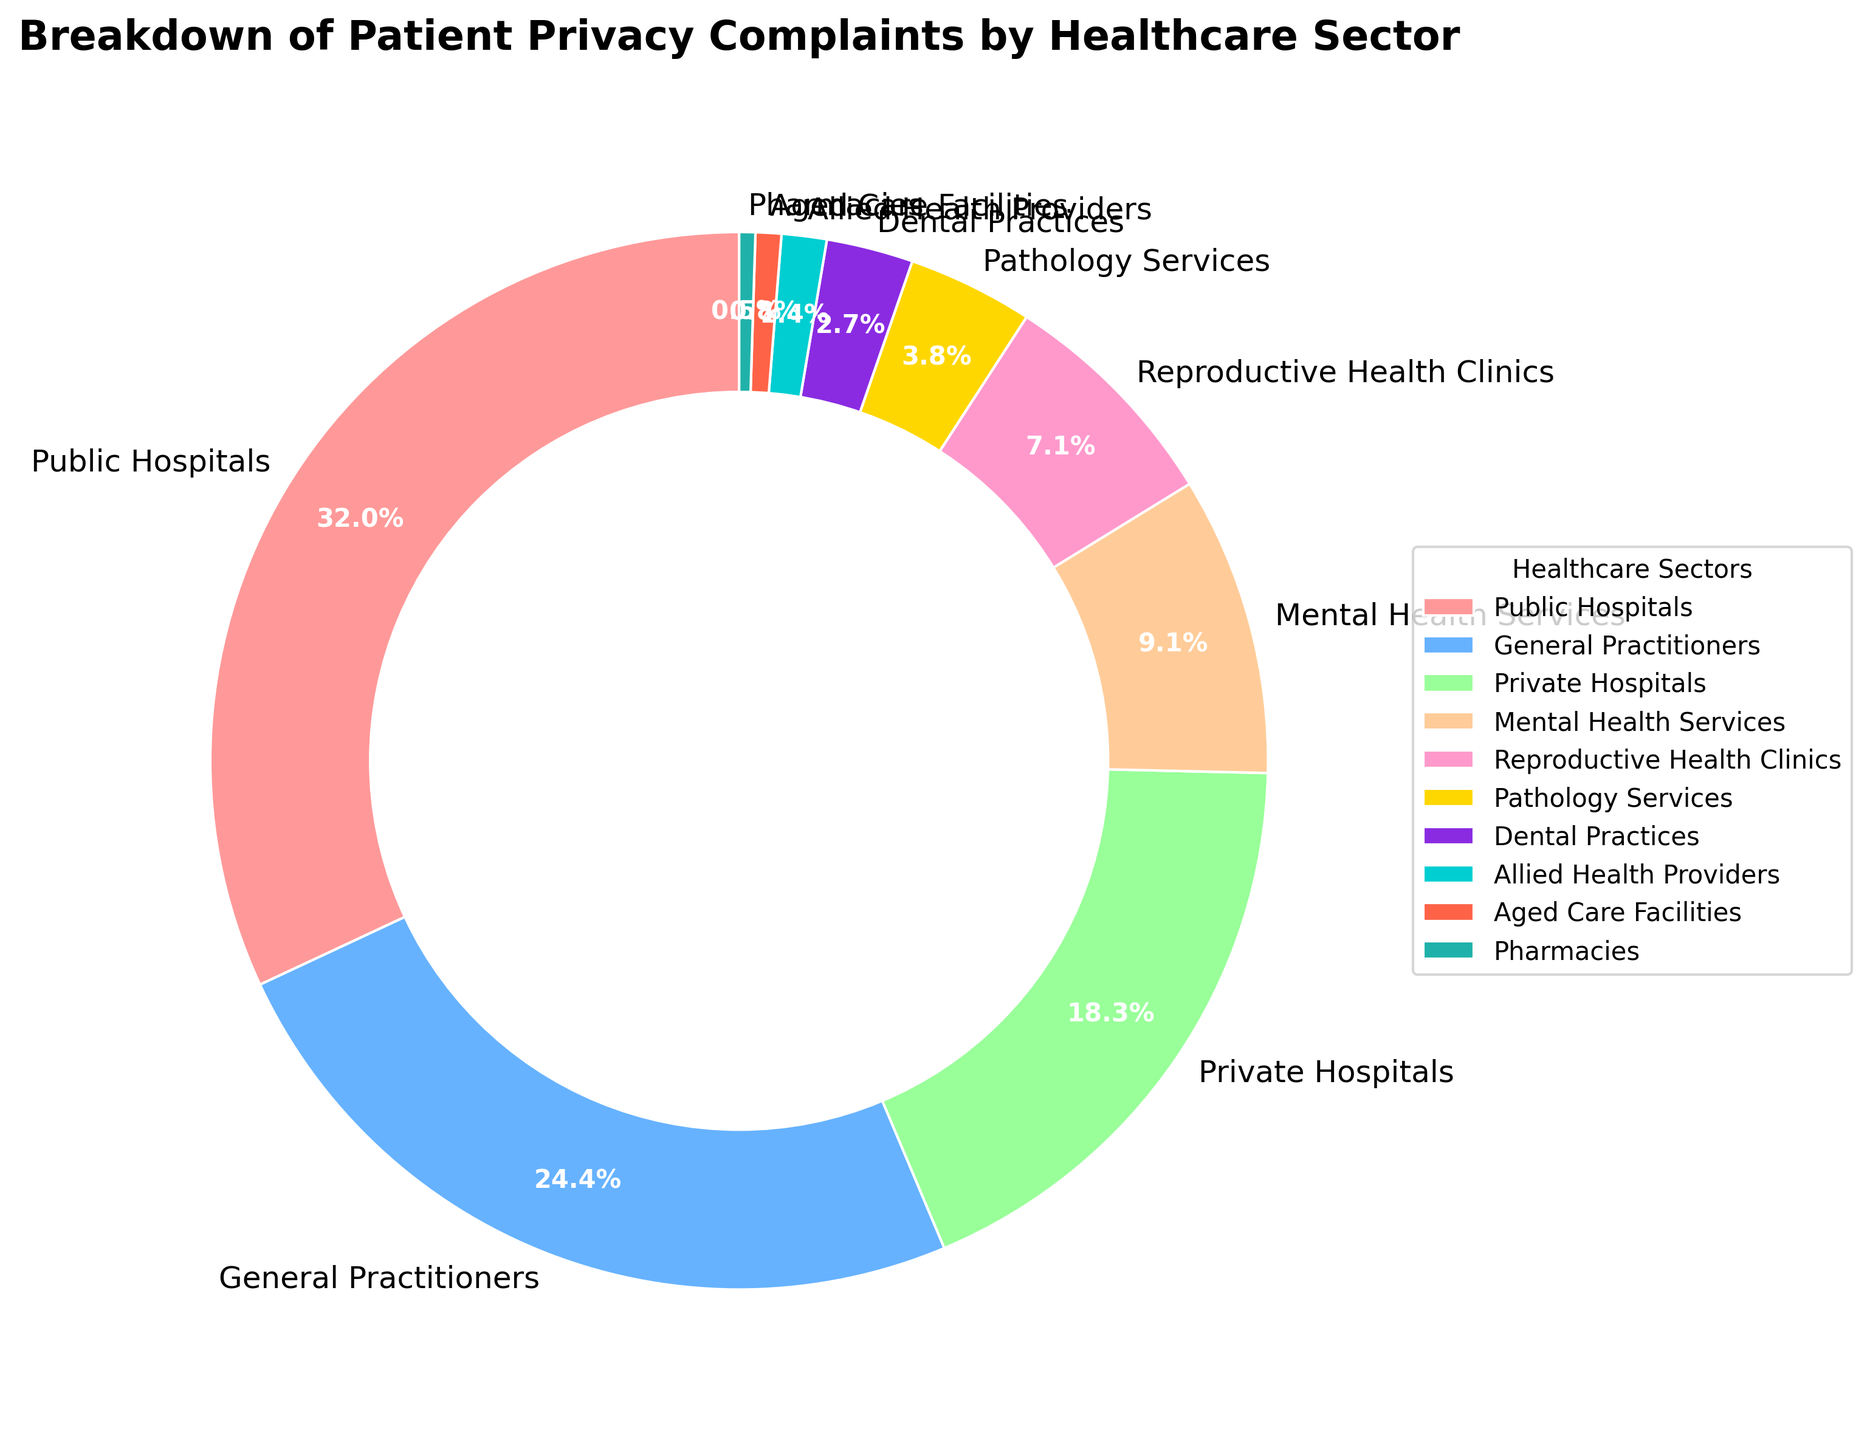Which sector has the highest percentage of patient privacy complaints? The figure shows that Public Hospitals have the highest percentage of patient privacy complaints compared to the other sectors, represented by the largest wedge in the pie chart.
Answer: Public Hospitals What is the combined percentage of patient privacy complaints for Private Hospitals and General Practitioners? Identifying the respective percentages from the pie chart, we see that Private Hospitals have 18.6% and General Practitioners have 24.8%. Summing these values gives 18.6% + 24.8% = 43.4%.
Answer: 43.4% Which sector has the smallest percentage of complaints, and what is this percentage? The pie chart shows that the smallest wedge corresponds to Pharmacies with the smallest percentage. The derived percentage is 0.5%.
Answer: Pharmacies, 0.5% How does the percentage of complaints in Mental Health Services compare to that in Reproductive Health Clinics? Examining the pie chart, the percentage for Mental Health Services is 9.3% and for Reproductive Health Clinics is 7.2%. By comparing these, we see that Mental Health Services have a higher percentage.
Answer: Mental Health Services have a higher percentage What percentage of complaints do Pathology Services, Dental Practices, and Allied Health Providers account for together? Adding the percentages of Pathology Services (3.9%), Dental Practices (2.7%), and Allied Health Providers (1.4%) from the pie chart gives 3.9% + 2.7% + 1.4% = 8.0%.
Answer: 8.0% Which sectors together account for over half of all patient privacy complaints? From the pie chart, identifying sectors and their respective percentages: 
Public Hospitals (32.5%), General Practitioners (24.8%), and Private Hospitals (18.6%) sum to 32.5% + 24.8% + 18.6% = 75.9%, which is over half.
Answer: Public Hospitals, General Practitioners, Private Hospitals What is the difference in the percentage of complaints between Pathology Services and Aged Care Facilities? Noting that Pathology Services have 3.9% and Aged Care Facilities have 0.8% from the pie chart, the difference is calculated as 3.9% - 0.8% = 3.1%.
Answer: 3.1% If the complaints in Dental Practices were doubled, what would the new percentage be? The current percentage for Dental Practices is 2.7%. Doubling this value gives 2.7% x 2 = 5.4%.
Answer: 5.4% What fraction of the total percentage do Allied Health Providers represent? The percentage for Allied Health Providers is 1.4%. Converting this to a fraction of the total 100%: 1.4 / 100 = 0.014, which simplifies to 7/500.
Answer: 7/500 